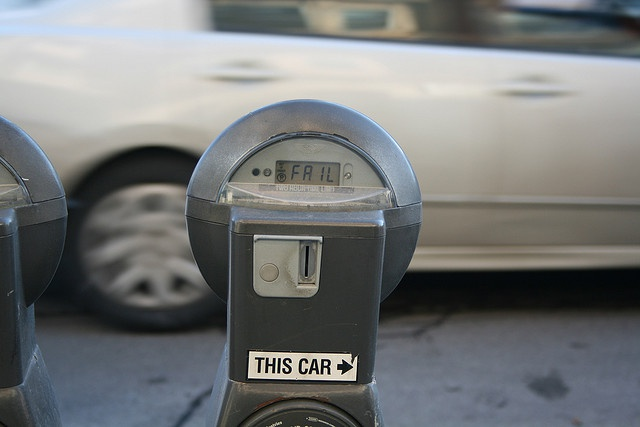Describe the objects in this image and their specific colors. I can see car in lightblue, lightgray, gray, darkgray, and black tones, parking meter in lightblue, black, gray, and darkgray tones, and parking meter in lightblue, black, gray, and blue tones in this image. 